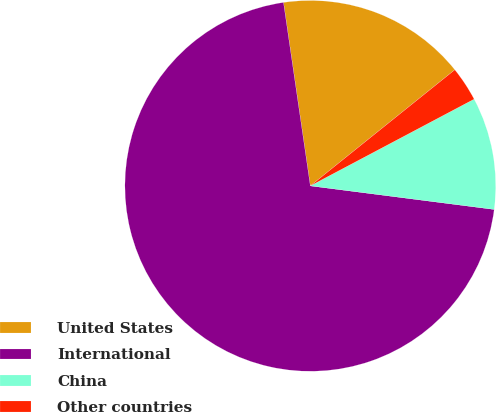<chart> <loc_0><loc_0><loc_500><loc_500><pie_chart><fcel>United States<fcel>International<fcel>China<fcel>Other countries<nl><fcel>16.54%<fcel>70.66%<fcel>9.78%<fcel>3.02%<nl></chart> 